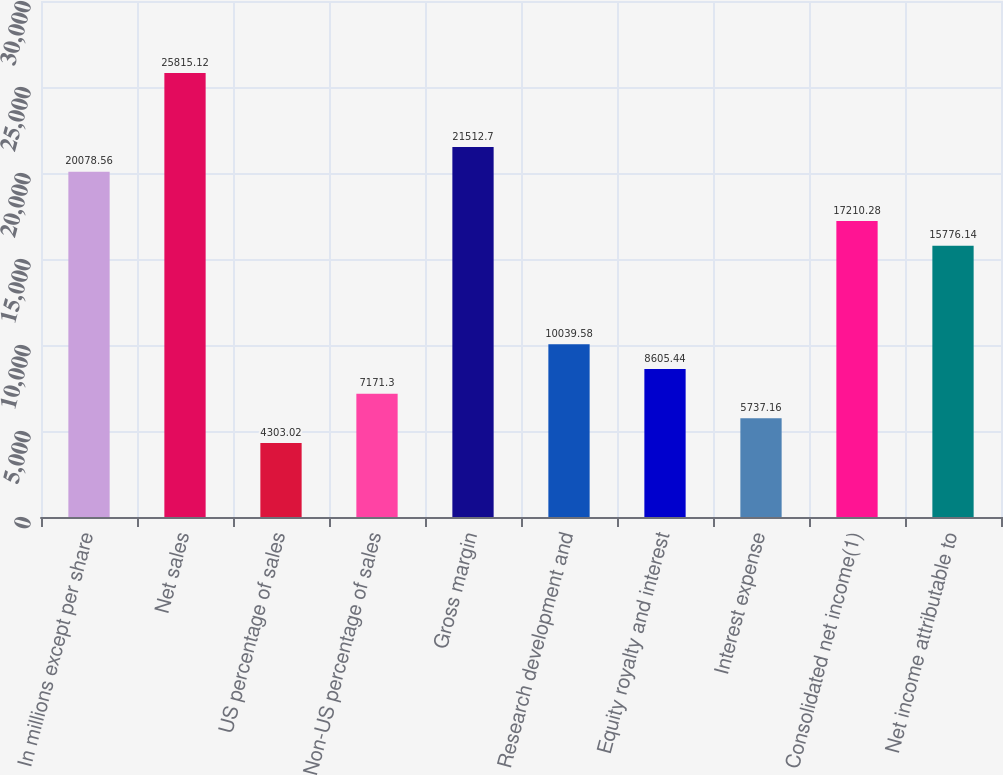Convert chart to OTSL. <chart><loc_0><loc_0><loc_500><loc_500><bar_chart><fcel>In millions except per share<fcel>Net sales<fcel>US percentage of sales<fcel>Non-US percentage of sales<fcel>Gross margin<fcel>Research development and<fcel>Equity royalty and interest<fcel>Interest expense<fcel>Consolidated net income(1)<fcel>Net income attributable to<nl><fcel>20078.6<fcel>25815.1<fcel>4303.02<fcel>7171.3<fcel>21512.7<fcel>10039.6<fcel>8605.44<fcel>5737.16<fcel>17210.3<fcel>15776.1<nl></chart> 